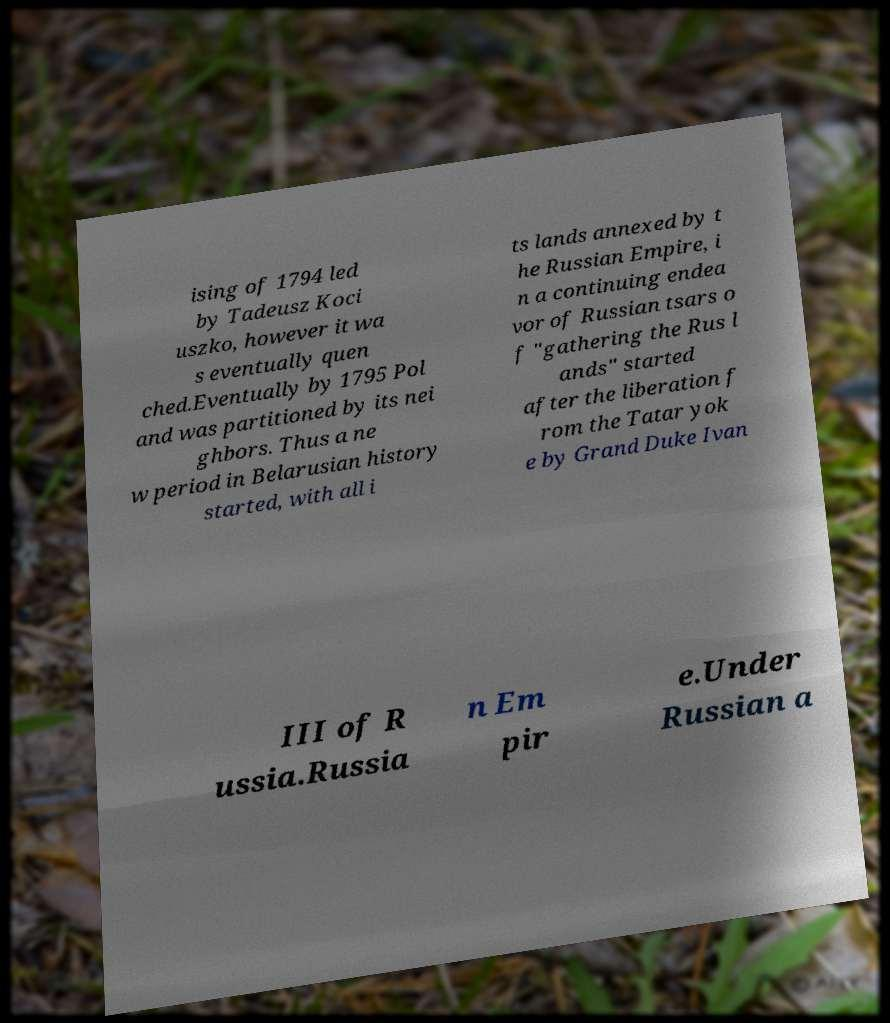For documentation purposes, I need the text within this image transcribed. Could you provide that? ising of 1794 led by Tadeusz Koci uszko, however it wa s eventually quen ched.Eventually by 1795 Pol and was partitioned by its nei ghbors. Thus a ne w period in Belarusian history started, with all i ts lands annexed by t he Russian Empire, i n a continuing endea vor of Russian tsars o f "gathering the Rus l ands" started after the liberation f rom the Tatar yok e by Grand Duke Ivan III of R ussia.Russia n Em pir e.Under Russian a 